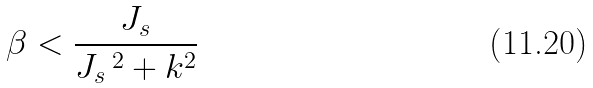Convert formula to latex. <formula><loc_0><loc_0><loc_500><loc_500>\beta < \frac { J _ { s } } { J _ { s } \, ^ { 2 } + k ^ { 2 } }</formula> 